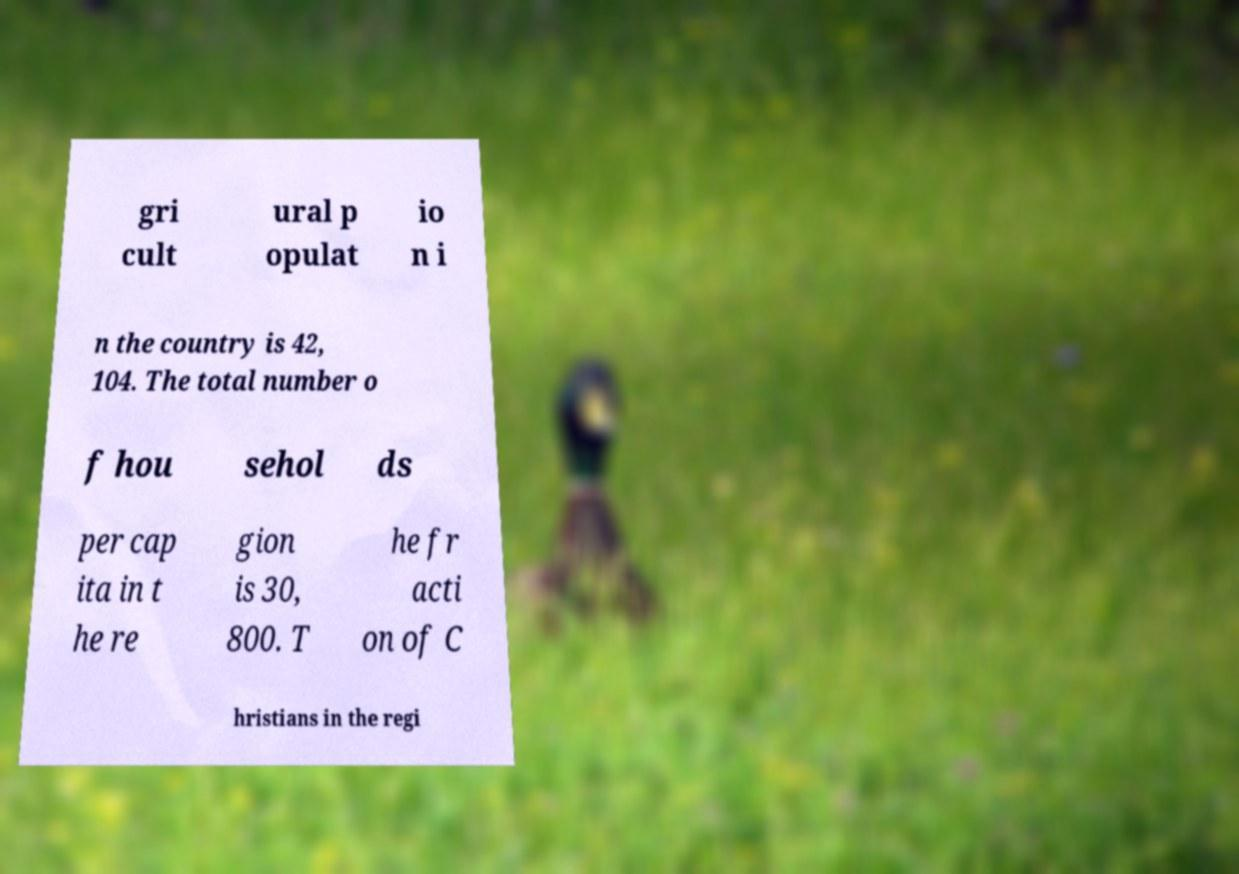Please read and relay the text visible in this image. What does it say? gri cult ural p opulat io n i n the country is 42, 104. The total number o f hou sehol ds per cap ita in t he re gion is 30, 800. T he fr acti on of C hristians in the regi 